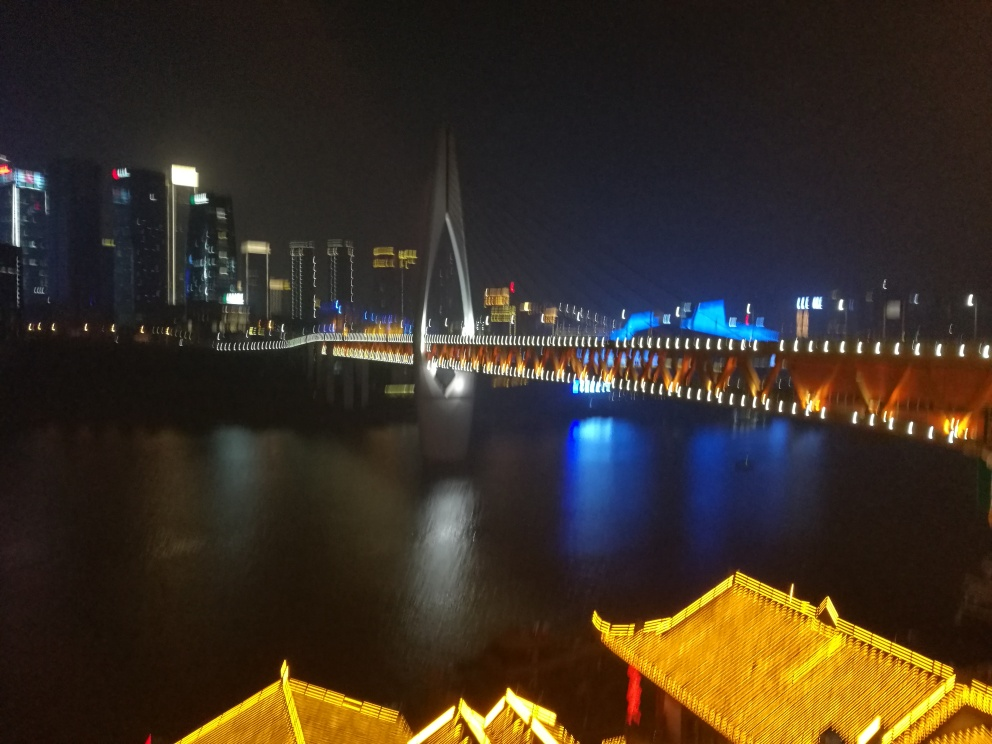Can you tell me what the focal point of this image is? The focal point of this image seems to be the brightly lit bridge with its unique architectural design. Its prominent position and lighting draw the viewer's eye as a central feature in the composition. 